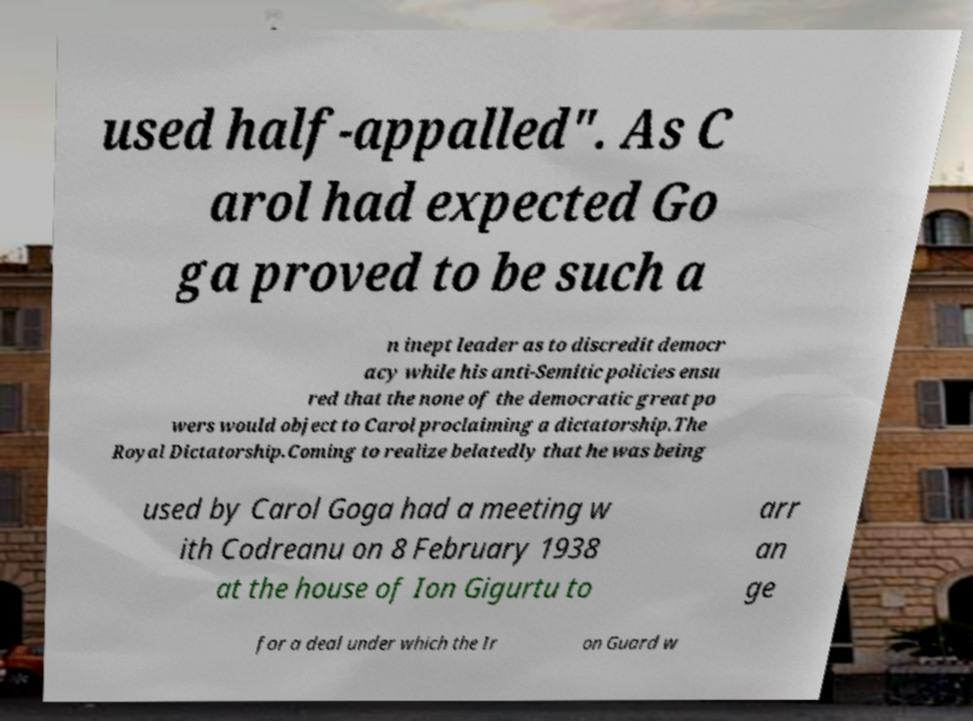Can you read and provide the text displayed in the image?This photo seems to have some interesting text. Can you extract and type it out for me? used half-appalled". As C arol had expected Go ga proved to be such a n inept leader as to discredit democr acy while his anti-Semitic policies ensu red that the none of the democratic great po wers would object to Carol proclaiming a dictatorship.The Royal Dictatorship.Coming to realize belatedly that he was being used by Carol Goga had a meeting w ith Codreanu on 8 February 1938 at the house of Ion Gigurtu to arr an ge for a deal under which the Ir on Guard w 